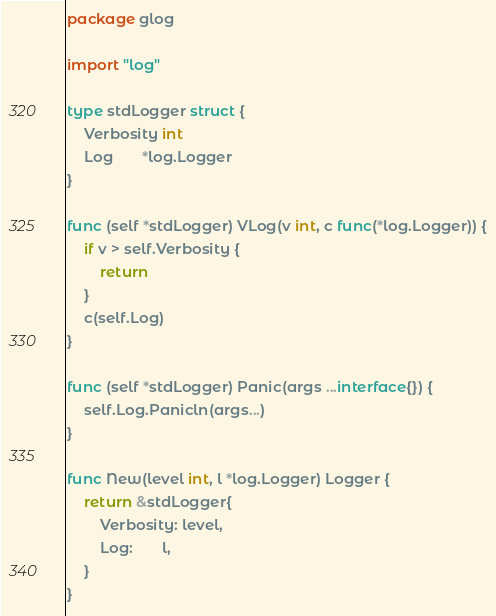Convert code to text. <code><loc_0><loc_0><loc_500><loc_500><_Go_>package glog

import "log"

type stdLogger struct {
	Verbosity int
	Log       *log.Logger
}

func (self *stdLogger) VLog(v int, c func(*log.Logger)) {
	if v > self.Verbosity {
		return
	}
	c(self.Log)
}

func (self *stdLogger) Panic(args ...interface{}) {
	self.Log.Panicln(args...)
}

func New(level int, l *log.Logger) Logger {
	return &stdLogger{
		Verbosity: level,
		Log:       l,
	}
}
</code> 